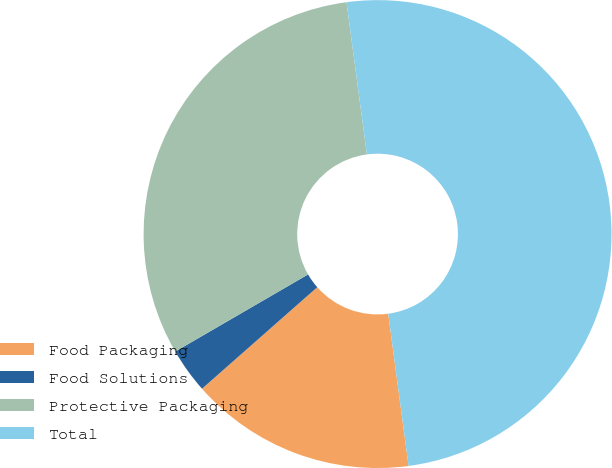Convert chart to OTSL. <chart><loc_0><loc_0><loc_500><loc_500><pie_chart><fcel>Food Packaging<fcel>Food Solutions<fcel>Protective Packaging<fcel>Total<nl><fcel>15.62%<fcel>3.12%<fcel>31.25%<fcel>50.0%<nl></chart> 